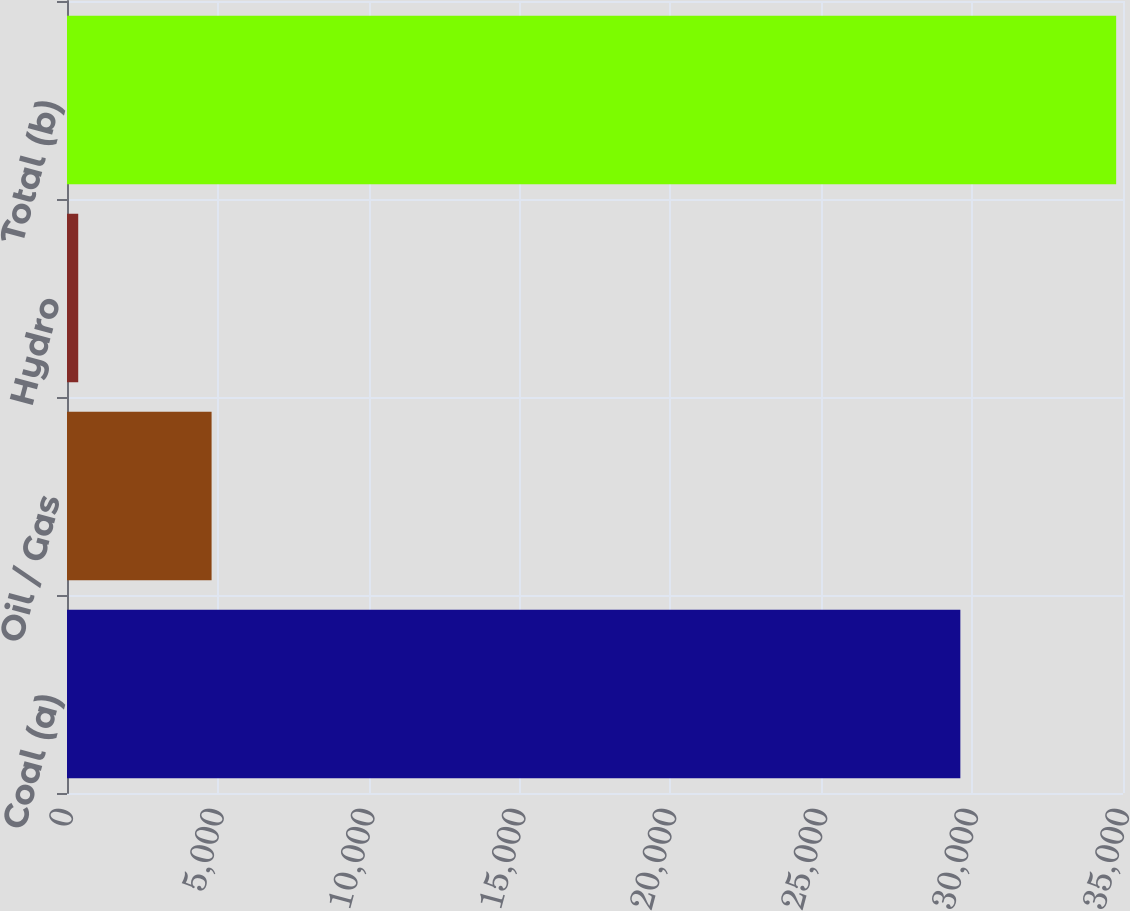<chart> <loc_0><loc_0><loc_500><loc_500><bar_chart><fcel>Coal (a)<fcel>Oil / Gas<fcel>Hydro<fcel>Total (b)<nl><fcel>29609<fcel>4792<fcel>372<fcel>34773<nl></chart> 